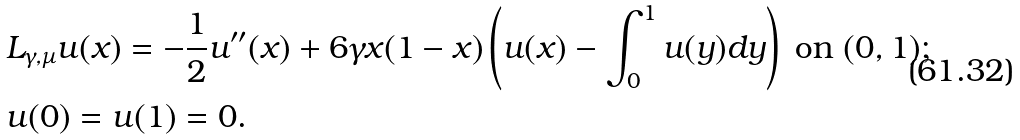Convert formula to latex. <formula><loc_0><loc_0><loc_500><loc_500>& L _ { \gamma , \mu } u ( x ) = - \frac { 1 } { 2 } u ^ { \prime \prime } ( x ) + 6 \gamma x ( 1 - x ) \left ( u ( x ) - \int _ { 0 } ^ { 1 } u ( y ) d y \right ) \ \text {on} \ ( 0 , 1 ) ; \\ & u ( 0 ) = u ( 1 ) = 0 .</formula> 